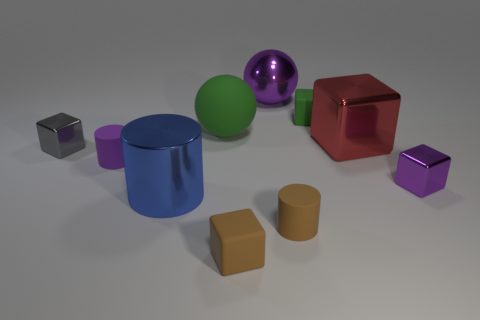How many other things are the same size as the purple ball?
Make the answer very short. 3. Is there a large purple metal thing that is in front of the metal cube that is in front of the metallic block left of the tiny brown rubber cylinder?
Give a very brief answer. No. Is there anything else of the same color as the big matte thing?
Offer a terse response. Yes. How big is the cylinder that is on the right side of the blue shiny object?
Make the answer very short. Small. There is a rubber cylinder that is to the left of the big object behind the small matte block behind the green matte ball; what size is it?
Offer a terse response. Small. The matte block in front of the matte object that is on the left side of the large shiny cylinder is what color?
Offer a very short reply. Brown. What is the material of the tiny brown thing that is the same shape as the big red thing?
Your response must be concise. Rubber. Are there any other things that are made of the same material as the purple cube?
Your answer should be compact. Yes. There is a large matte object; are there any large purple shiny balls in front of it?
Offer a terse response. No. What number of purple metal cubes are there?
Your answer should be very brief. 1. 